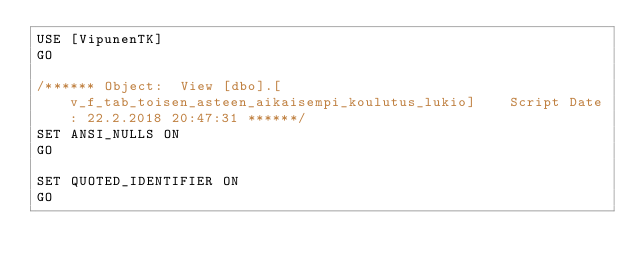Convert code to text. <code><loc_0><loc_0><loc_500><loc_500><_SQL_>USE [VipunenTK]
GO

/****** Object:  View [dbo].[v_f_tab_toisen_asteen_aikaisempi_koulutus_lukio]    Script Date: 22.2.2018 20:47:31 ******/
SET ANSI_NULLS ON
GO

SET QUOTED_IDENTIFIER ON
GO










</code> 